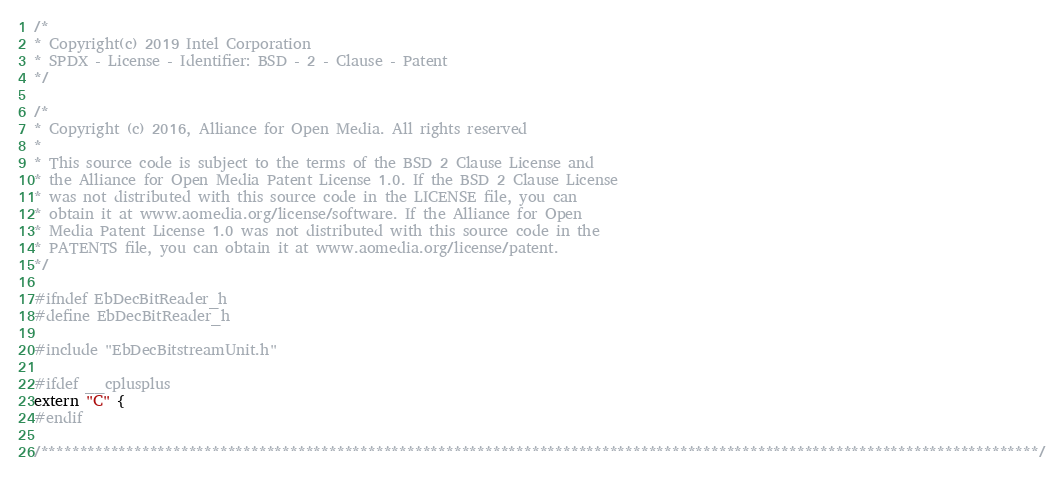<code> <loc_0><loc_0><loc_500><loc_500><_C_>/*
* Copyright(c) 2019 Intel Corporation
* SPDX - License - Identifier: BSD - 2 - Clause - Patent
*/

/*
* Copyright (c) 2016, Alliance for Open Media. All rights reserved
*
* This source code is subject to the terms of the BSD 2 Clause License and
* the Alliance for Open Media Patent License 1.0. If the BSD 2 Clause License
* was not distributed with this source code in the LICENSE file, you can
* obtain it at www.aomedia.org/license/software. If the Alliance for Open
* Media Patent License 1.0 was not distributed with this source code in the
* PATENTS file, you can obtain it at www.aomedia.org/license/patent.
*/

#ifndef EbDecBitReader_h
#define EbDecBitReader_h

#include "EbDecBitstreamUnit.h"

#ifdef __cplusplus
extern "C" {
#endif

/********************************************************************************************************************************/</code> 